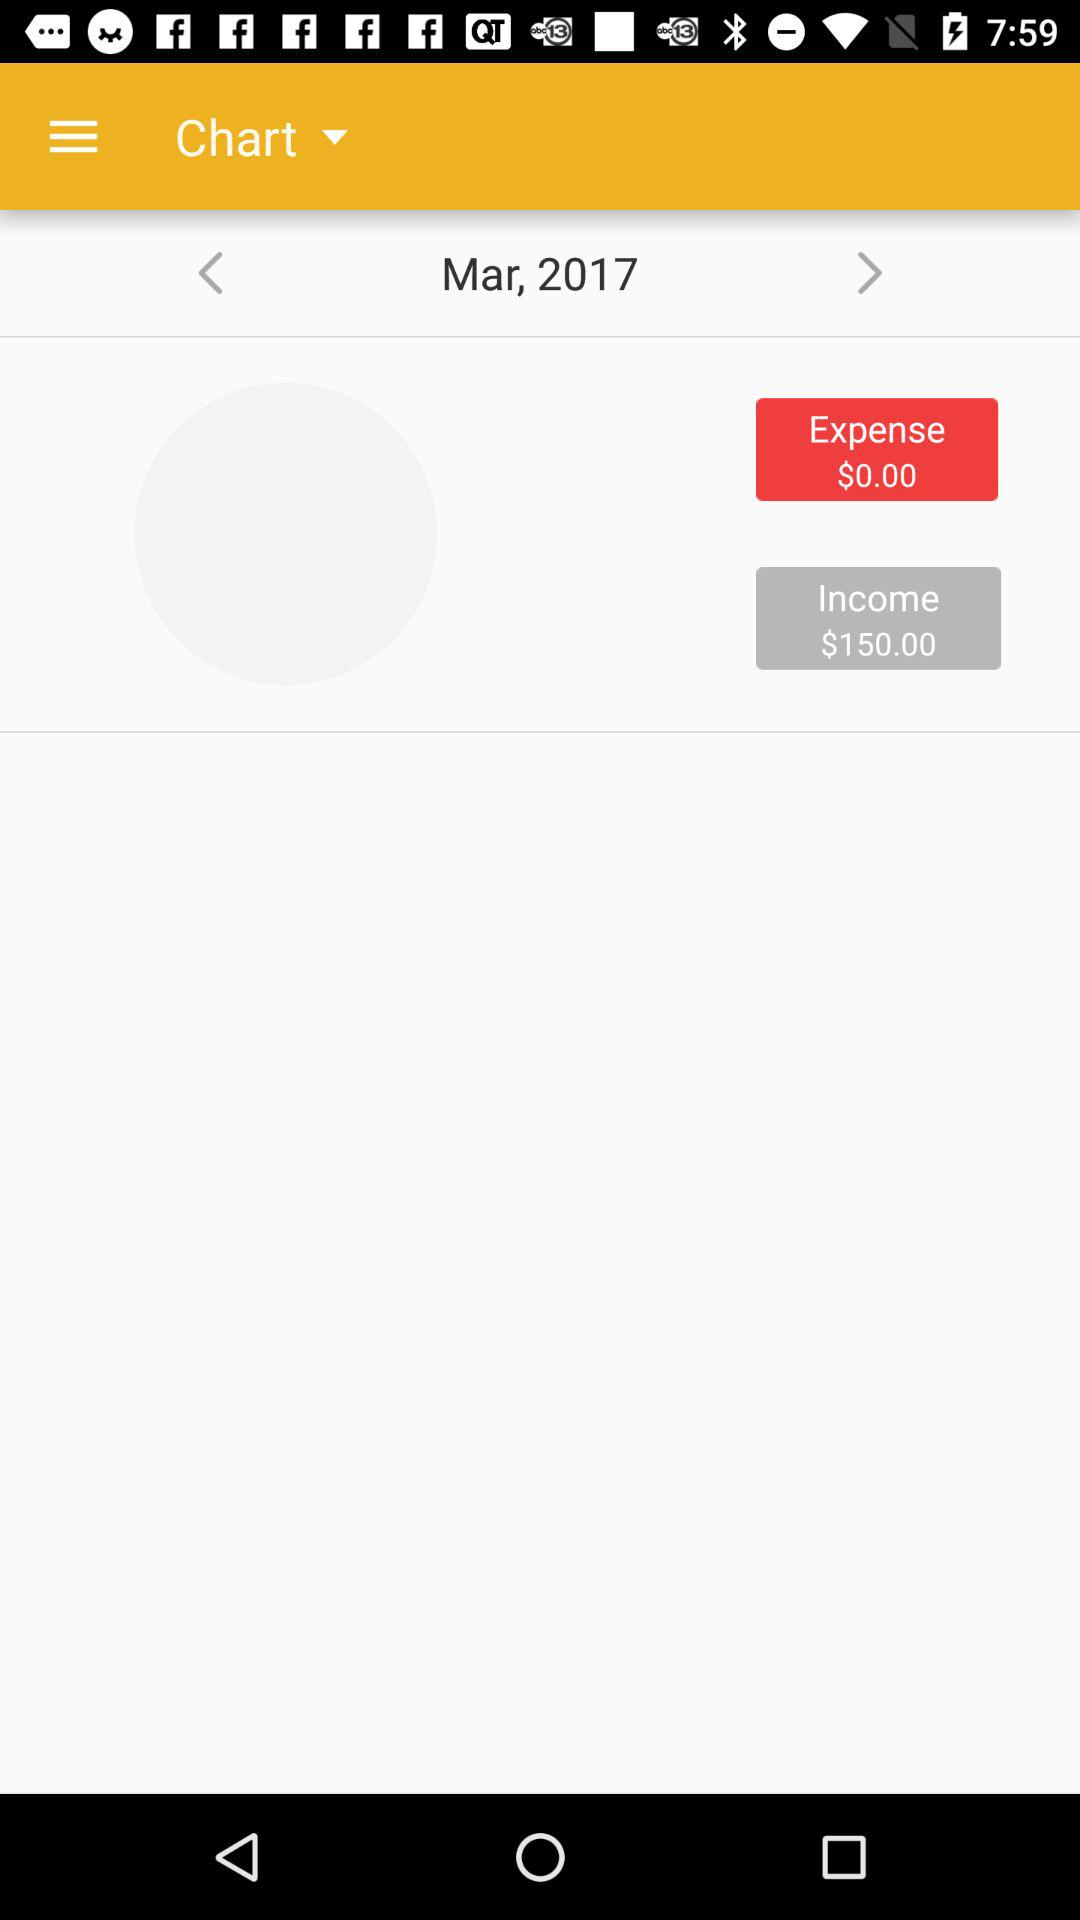How much more is the income than the expense?
Answer the question using a single word or phrase. $150.00 